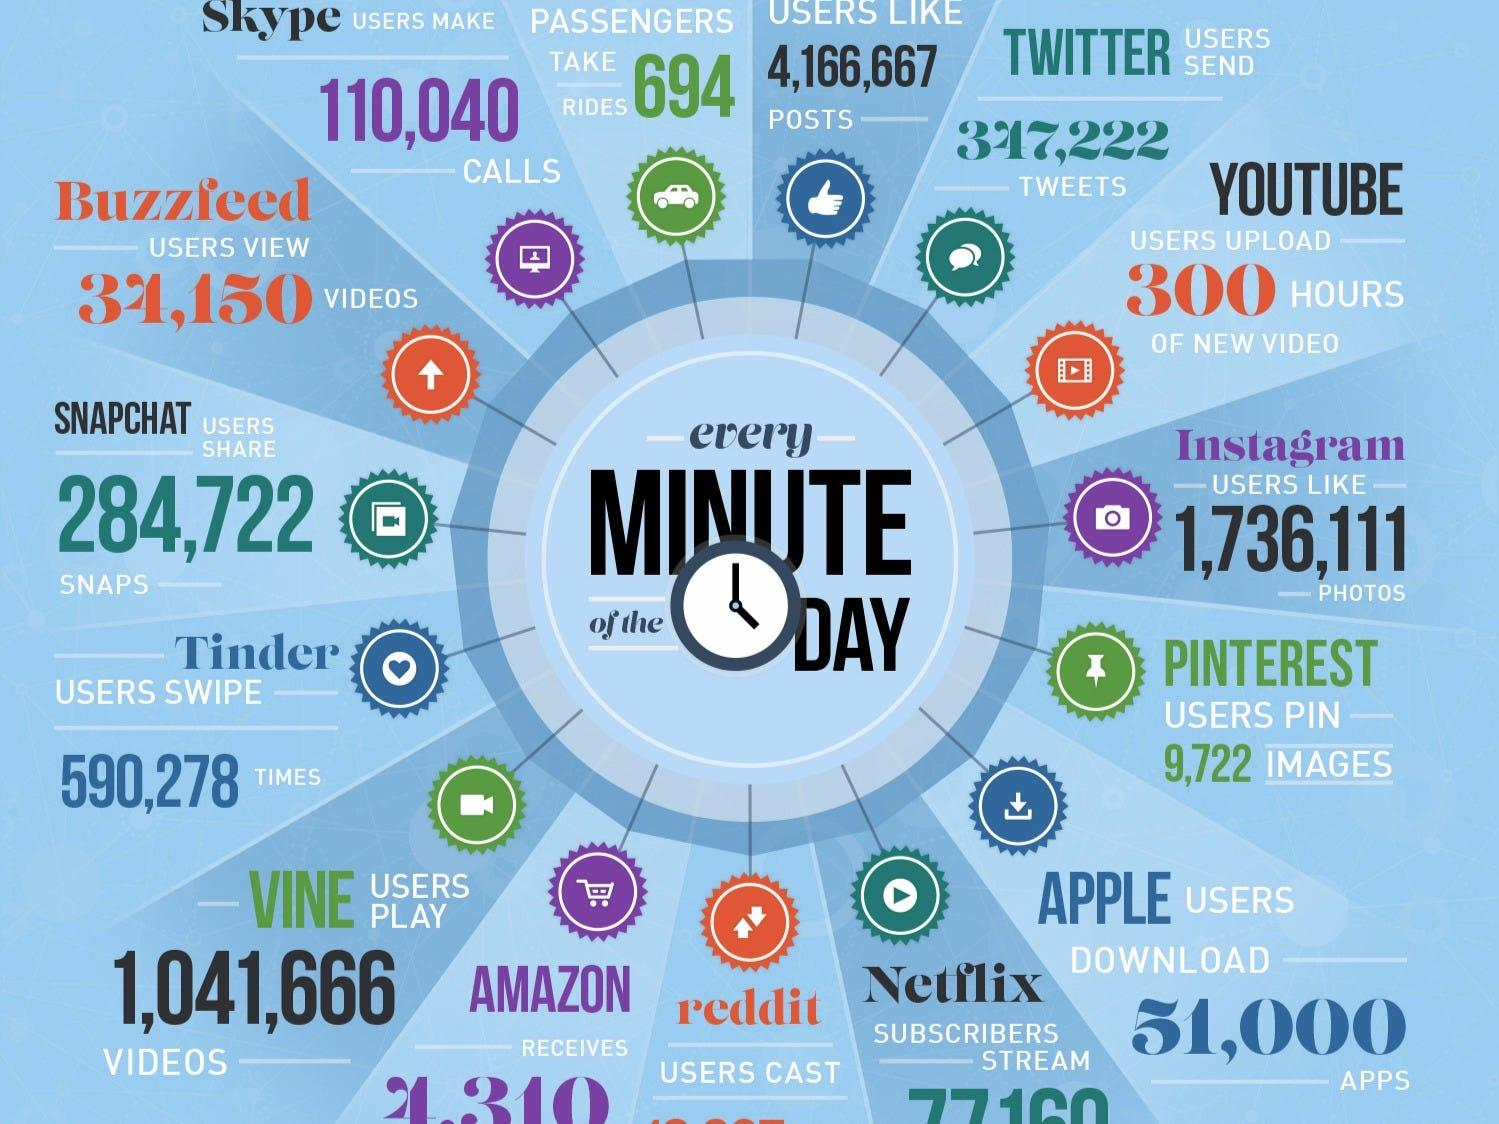Point out several critical features in this image. The apps that are designated in violet color are Skype, Instagram, and Amazon. The number of users who have given likes to articles is 4,166,667. The following apps are denoted in orange color: Buzzfeed, Youtube, and Reddit. 